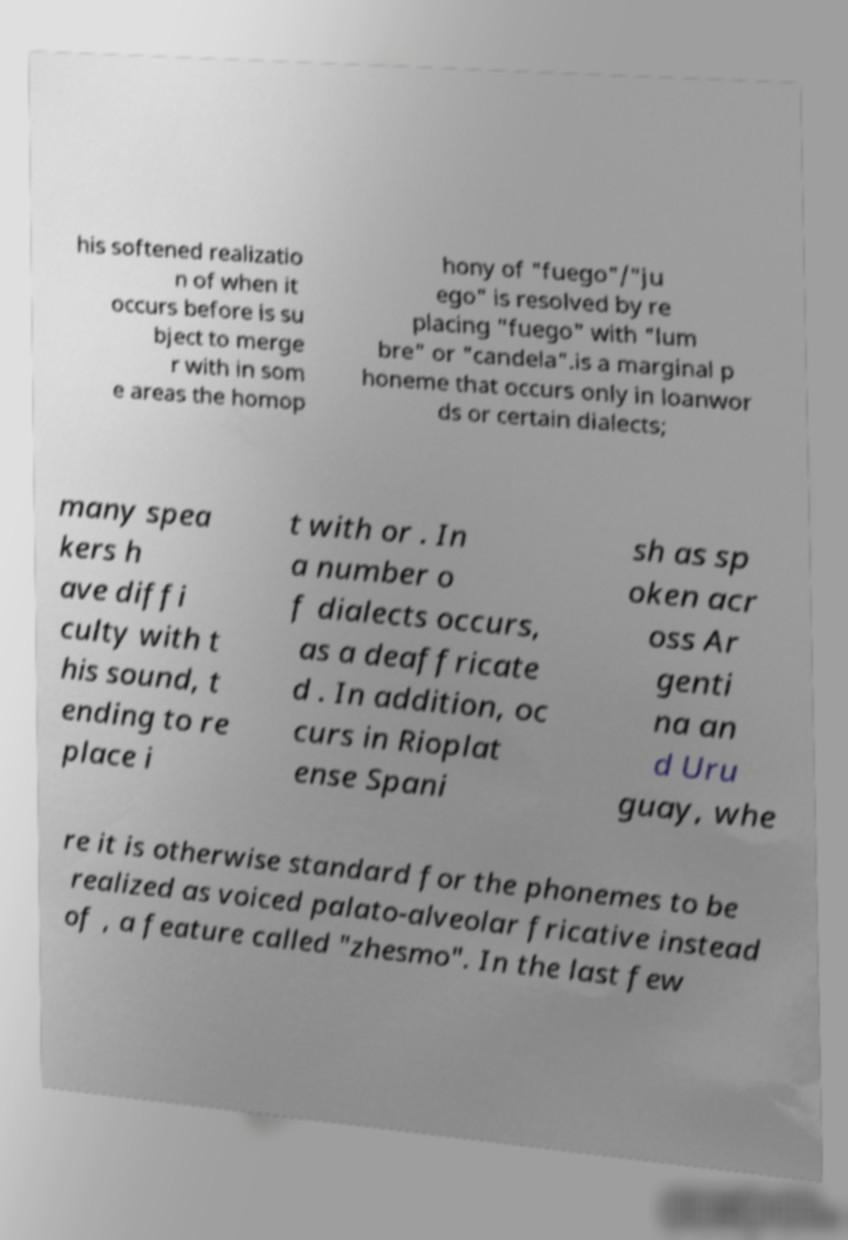Please identify and transcribe the text found in this image. his softened realizatio n of when it occurs before is su bject to merge r with in som e areas the homop hony of "fuego"/"ju ego" is resolved by re placing "fuego" with "lum bre" or "candela".is a marginal p honeme that occurs only in loanwor ds or certain dialects; many spea kers h ave diffi culty with t his sound, t ending to re place i t with or . In a number o f dialects occurs, as a deaffricate d . In addition, oc curs in Rioplat ense Spani sh as sp oken acr oss Ar genti na an d Uru guay, whe re it is otherwise standard for the phonemes to be realized as voiced palato-alveolar fricative instead of , a feature called "zhesmo". In the last few 